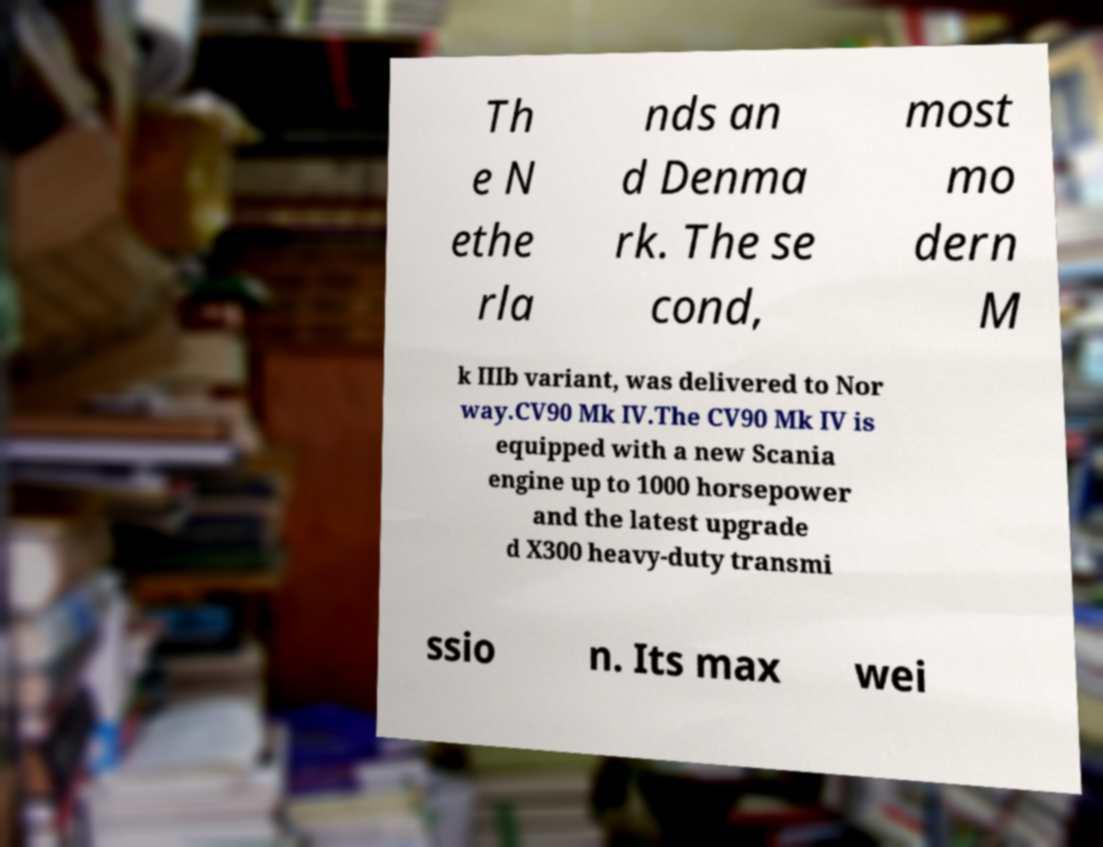What messages or text are displayed in this image? I need them in a readable, typed format. Th e N ethe rla nds an d Denma rk. The se cond, most mo dern M k IIIb variant, was delivered to Nor way.CV90 Mk IV.The CV90 Mk IV is equipped with a new Scania engine up to 1000 horsepower and the latest upgrade d X300 heavy-duty transmi ssio n. Its max wei 